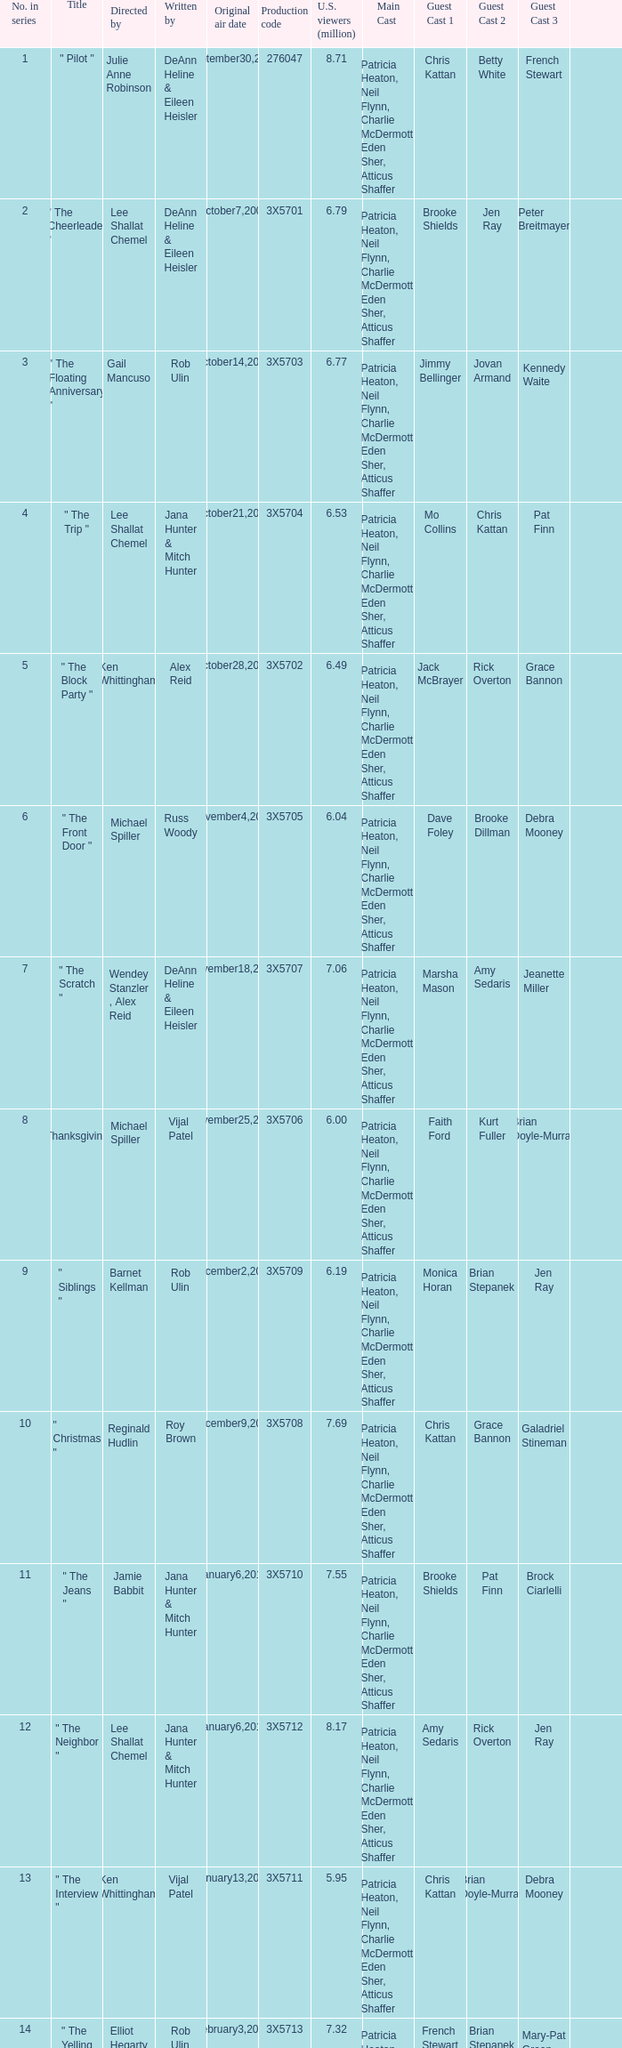Who wrote the episode that got 5.95 million U.S. viewers? Vijal Patel. 